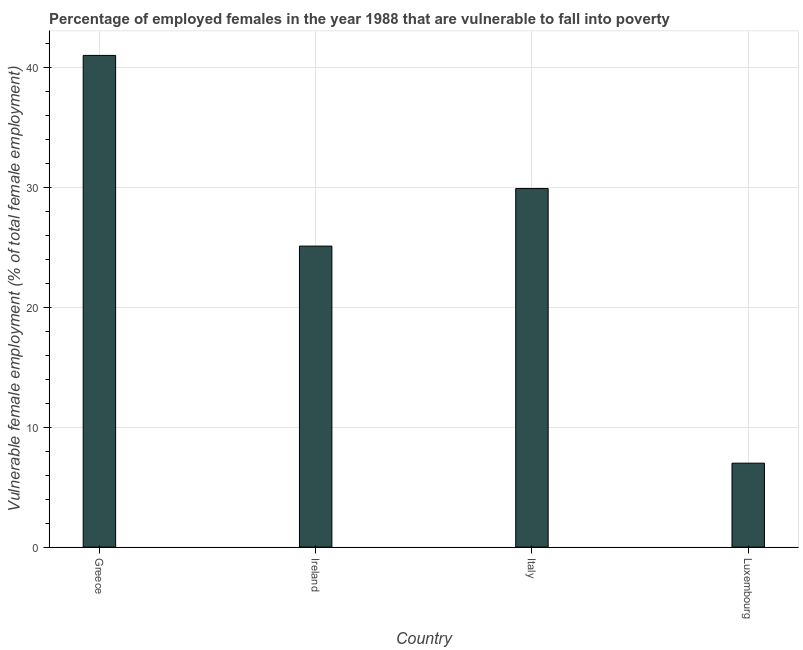Does the graph contain any zero values?
Ensure brevity in your answer.  No. What is the title of the graph?
Give a very brief answer. Percentage of employed females in the year 1988 that are vulnerable to fall into poverty. What is the label or title of the Y-axis?
Keep it short and to the point. Vulnerable female employment (% of total female employment). What is the percentage of employed females who are vulnerable to fall into poverty in Greece?
Offer a very short reply. 41. Across all countries, what is the maximum percentage of employed females who are vulnerable to fall into poverty?
Your response must be concise. 41. Across all countries, what is the minimum percentage of employed females who are vulnerable to fall into poverty?
Give a very brief answer. 7. In which country was the percentage of employed females who are vulnerable to fall into poverty minimum?
Keep it short and to the point. Luxembourg. What is the sum of the percentage of employed females who are vulnerable to fall into poverty?
Provide a succinct answer. 103. What is the difference between the percentage of employed females who are vulnerable to fall into poverty in Greece and Italy?
Offer a very short reply. 11.1. What is the average percentage of employed females who are vulnerable to fall into poverty per country?
Your response must be concise. 25.75. What is the ratio of the percentage of employed females who are vulnerable to fall into poverty in Greece to that in Ireland?
Your response must be concise. 1.63. Is the difference between the percentage of employed females who are vulnerable to fall into poverty in Greece and Ireland greater than the difference between any two countries?
Give a very brief answer. No. What is the difference between the highest and the second highest percentage of employed females who are vulnerable to fall into poverty?
Provide a short and direct response. 11.1. How many bars are there?
Ensure brevity in your answer.  4. Are the values on the major ticks of Y-axis written in scientific E-notation?
Your response must be concise. No. What is the Vulnerable female employment (% of total female employment) of Ireland?
Ensure brevity in your answer.  25.1. What is the Vulnerable female employment (% of total female employment) of Italy?
Ensure brevity in your answer.  29.9. What is the difference between the Vulnerable female employment (% of total female employment) in Greece and Ireland?
Provide a succinct answer. 15.9. What is the difference between the Vulnerable female employment (% of total female employment) in Greece and Italy?
Your answer should be compact. 11.1. What is the difference between the Vulnerable female employment (% of total female employment) in Ireland and Italy?
Provide a succinct answer. -4.8. What is the difference between the Vulnerable female employment (% of total female employment) in Italy and Luxembourg?
Offer a very short reply. 22.9. What is the ratio of the Vulnerable female employment (% of total female employment) in Greece to that in Ireland?
Offer a very short reply. 1.63. What is the ratio of the Vulnerable female employment (% of total female employment) in Greece to that in Italy?
Your response must be concise. 1.37. What is the ratio of the Vulnerable female employment (% of total female employment) in Greece to that in Luxembourg?
Your response must be concise. 5.86. What is the ratio of the Vulnerable female employment (% of total female employment) in Ireland to that in Italy?
Make the answer very short. 0.84. What is the ratio of the Vulnerable female employment (% of total female employment) in Ireland to that in Luxembourg?
Keep it short and to the point. 3.59. What is the ratio of the Vulnerable female employment (% of total female employment) in Italy to that in Luxembourg?
Your answer should be compact. 4.27. 